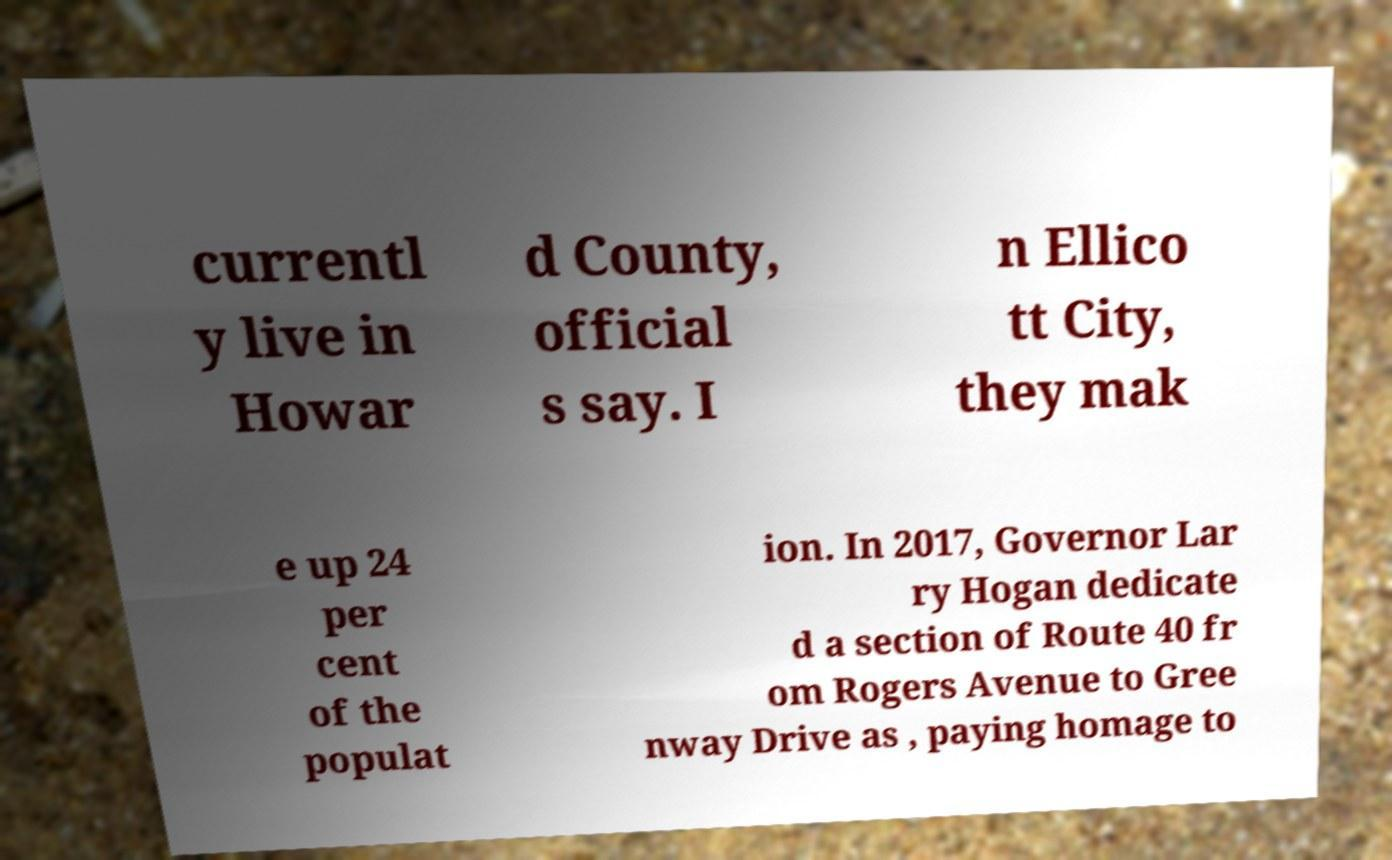Please read and relay the text visible in this image. What does it say? currentl y live in Howar d County, official s say. I n Ellico tt City, they mak e up 24 per cent of the populat ion. In 2017, Governor Lar ry Hogan dedicate d a section of Route 40 fr om Rogers Avenue to Gree nway Drive as , paying homage to 